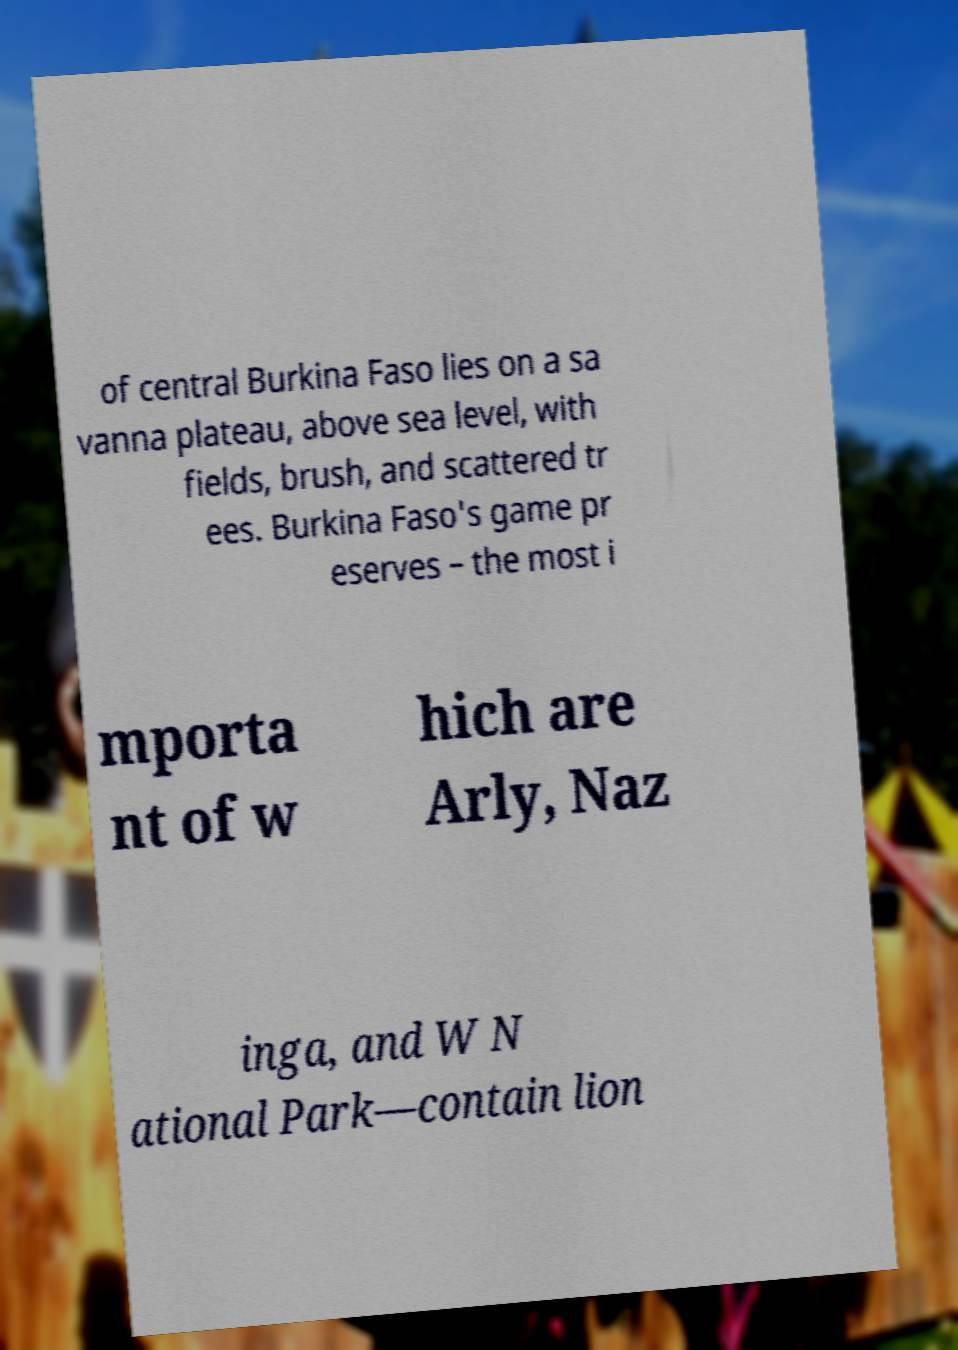What messages or text are displayed in this image? I need them in a readable, typed format. of central Burkina Faso lies on a sa vanna plateau, above sea level, with fields, brush, and scattered tr ees. Burkina Faso's game pr eserves – the most i mporta nt of w hich are Arly, Naz inga, and W N ational Park—contain lion 